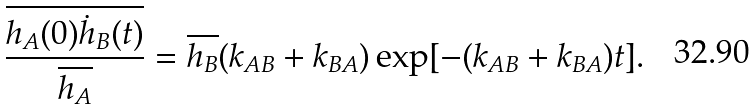<formula> <loc_0><loc_0><loc_500><loc_500>\frac { \overline { h _ { A } ( 0 ) \dot { h } _ { B } ( t ) } } { \overline { h _ { A } } } = \overline { h _ { B } } ( k _ { A B } + k _ { B A } ) \exp [ - ( k _ { A B } + k _ { B A } ) t ] .</formula> 